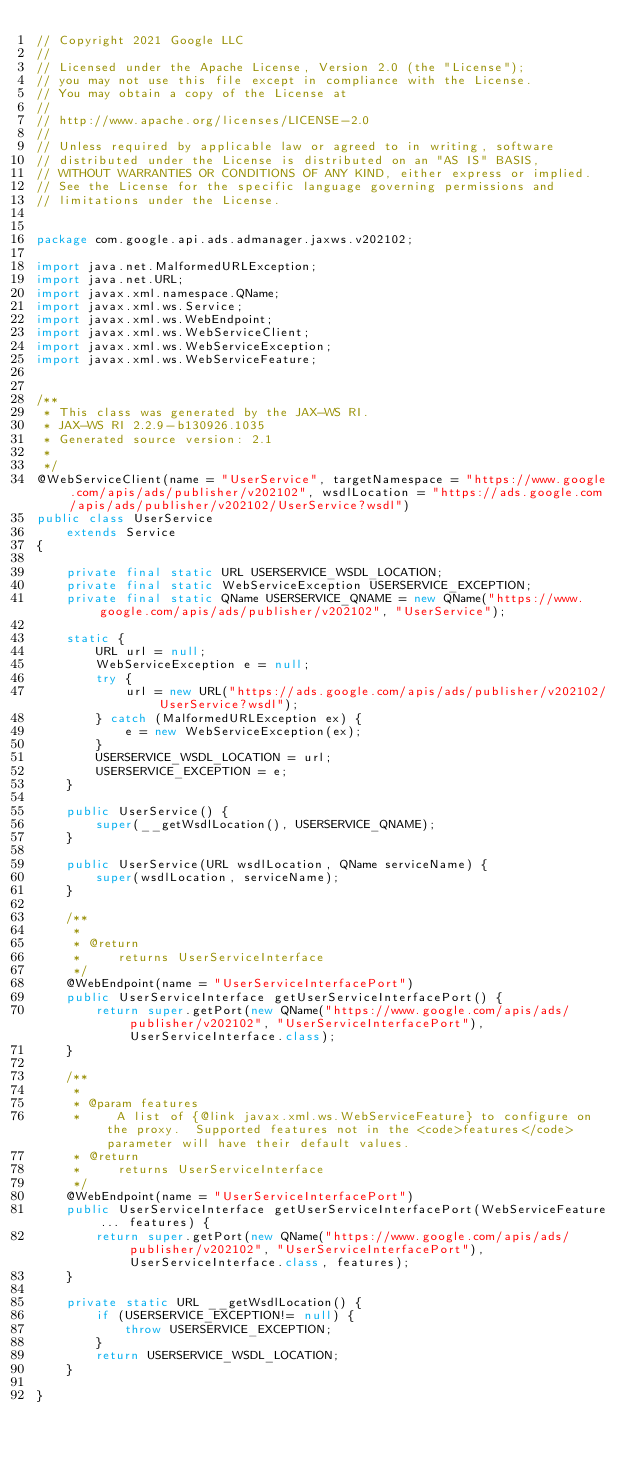<code> <loc_0><loc_0><loc_500><loc_500><_Java_>// Copyright 2021 Google LLC
//
// Licensed under the Apache License, Version 2.0 (the "License");
// you may not use this file except in compliance with the License.
// You may obtain a copy of the License at
//
// http://www.apache.org/licenses/LICENSE-2.0
//
// Unless required by applicable law or agreed to in writing, software
// distributed under the License is distributed on an "AS IS" BASIS,
// WITHOUT WARRANTIES OR CONDITIONS OF ANY KIND, either express or implied.
// See the License for the specific language governing permissions and
// limitations under the License.


package com.google.api.ads.admanager.jaxws.v202102;

import java.net.MalformedURLException;
import java.net.URL;
import javax.xml.namespace.QName;
import javax.xml.ws.Service;
import javax.xml.ws.WebEndpoint;
import javax.xml.ws.WebServiceClient;
import javax.xml.ws.WebServiceException;
import javax.xml.ws.WebServiceFeature;


/**
 * This class was generated by the JAX-WS RI.
 * JAX-WS RI 2.2.9-b130926.1035
 * Generated source version: 2.1
 * 
 */
@WebServiceClient(name = "UserService", targetNamespace = "https://www.google.com/apis/ads/publisher/v202102", wsdlLocation = "https://ads.google.com/apis/ads/publisher/v202102/UserService?wsdl")
public class UserService
    extends Service
{

    private final static URL USERSERVICE_WSDL_LOCATION;
    private final static WebServiceException USERSERVICE_EXCEPTION;
    private final static QName USERSERVICE_QNAME = new QName("https://www.google.com/apis/ads/publisher/v202102", "UserService");

    static {
        URL url = null;
        WebServiceException e = null;
        try {
            url = new URL("https://ads.google.com/apis/ads/publisher/v202102/UserService?wsdl");
        } catch (MalformedURLException ex) {
            e = new WebServiceException(ex);
        }
        USERSERVICE_WSDL_LOCATION = url;
        USERSERVICE_EXCEPTION = e;
    }

    public UserService() {
        super(__getWsdlLocation(), USERSERVICE_QNAME);
    }

    public UserService(URL wsdlLocation, QName serviceName) {
        super(wsdlLocation, serviceName);
    }

    /**
     * 
     * @return
     *     returns UserServiceInterface
     */
    @WebEndpoint(name = "UserServiceInterfacePort")
    public UserServiceInterface getUserServiceInterfacePort() {
        return super.getPort(new QName("https://www.google.com/apis/ads/publisher/v202102", "UserServiceInterfacePort"), UserServiceInterface.class);
    }

    /**
     * 
     * @param features
     *     A list of {@link javax.xml.ws.WebServiceFeature} to configure on the proxy.  Supported features not in the <code>features</code> parameter will have their default values.
     * @return
     *     returns UserServiceInterface
     */
    @WebEndpoint(name = "UserServiceInterfacePort")
    public UserServiceInterface getUserServiceInterfacePort(WebServiceFeature... features) {
        return super.getPort(new QName("https://www.google.com/apis/ads/publisher/v202102", "UserServiceInterfacePort"), UserServiceInterface.class, features);
    }

    private static URL __getWsdlLocation() {
        if (USERSERVICE_EXCEPTION!= null) {
            throw USERSERVICE_EXCEPTION;
        }
        return USERSERVICE_WSDL_LOCATION;
    }

}
</code> 